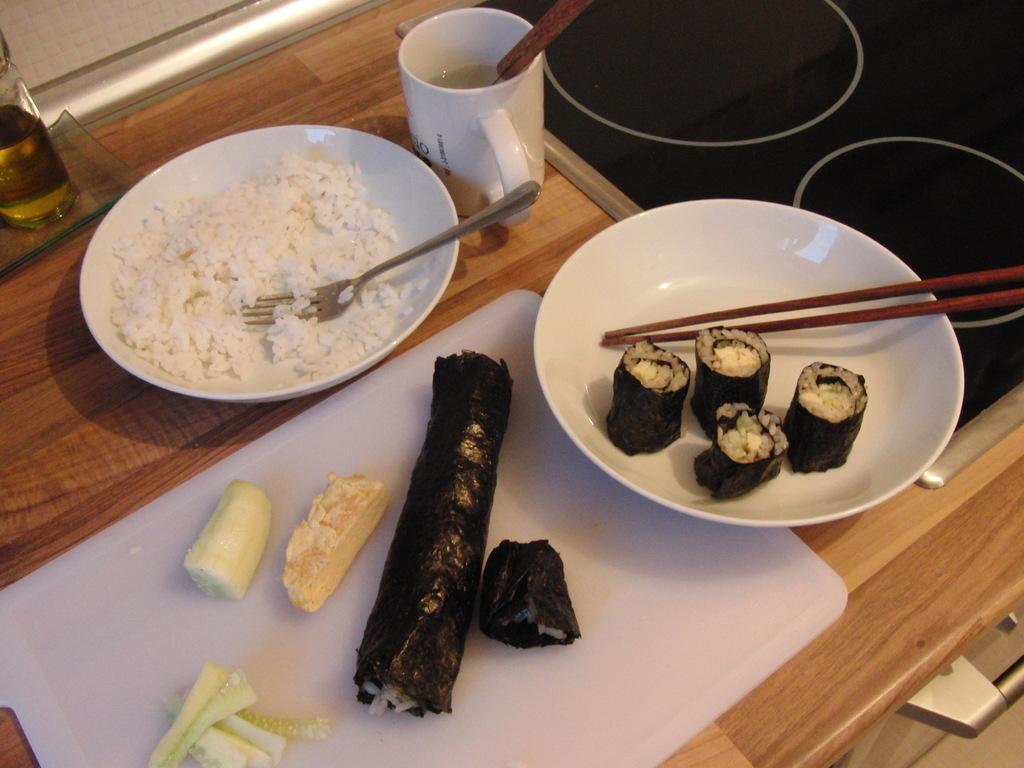Describe this image in one or two sentences. There is a table with plate,rice and fork in it. another tray with salad in it. And another tray with chopsticks and food. There is a bottle with oil at left side corner. 